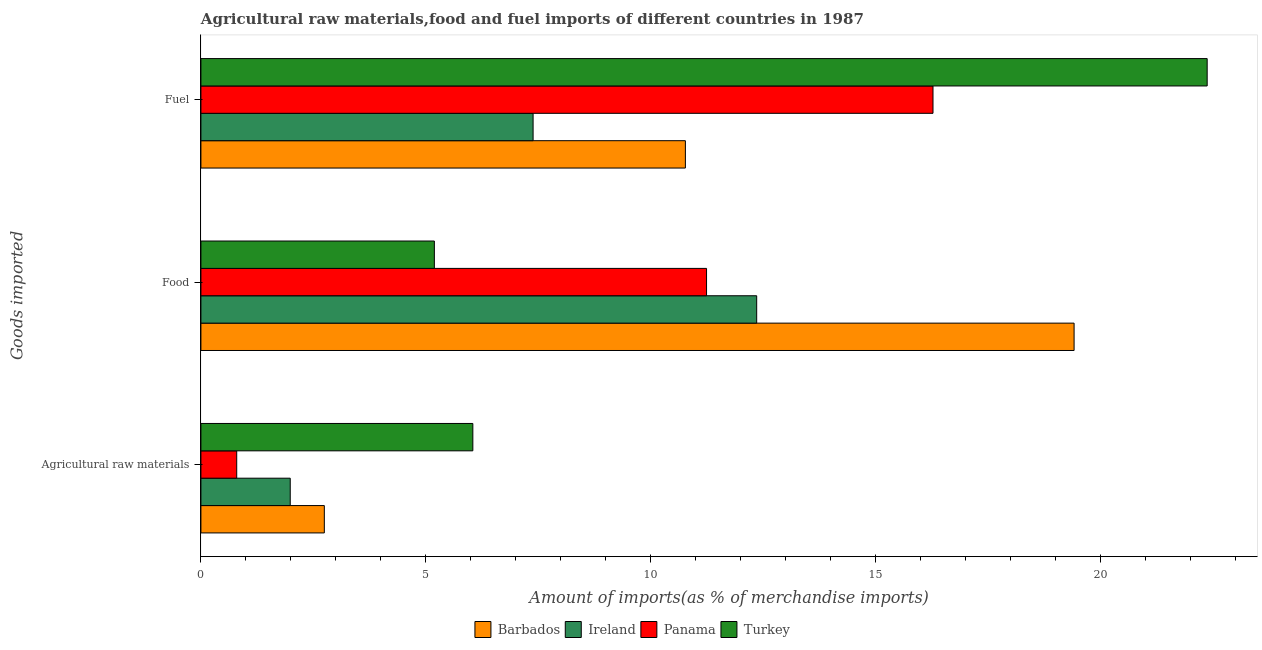How many different coloured bars are there?
Offer a very short reply. 4. How many bars are there on the 3rd tick from the top?
Provide a short and direct response. 4. What is the label of the 3rd group of bars from the top?
Offer a terse response. Agricultural raw materials. What is the percentage of fuel imports in Ireland?
Your answer should be very brief. 7.38. Across all countries, what is the maximum percentage of food imports?
Provide a succinct answer. 19.41. Across all countries, what is the minimum percentage of fuel imports?
Give a very brief answer. 7.38. In which country was the percentage of fuel imports maximum?
Your answer should be compact. Turkey. In which country was the percentage of fuel imports minimum?
Provide a succinct answer. Ireland. What is the total percentage of fuel imports in the graph?
Provide a short and direct response. 56.78. What is the difference between the percentage of fuel imports in Ireland and that in Panama?
Provide a short and direct response. -8.89. What is the difference between the percentage of raw materials imports in Ireland and the percentage of food imports in Turkey?
Your response must be concise. -3.2. What is the average percentage of fuel imports per country?
Your response must be concise. 14.2. What is the difference between the percentage of raw materials imports and percentage of food imports in Ireland?
Offer a terse response. -10.37. In how many countries, is the percentage of fuel imports greater than 12 %?
Keep it short and to the point. 2. What is the ratio of the percentage of raw materials imports in Turkey to that in Barbados?
Give a very brief answer. 2.2. Is the percentage of food imports in Turkey less than that in Panama?
Your answer should be compact. Yes. Is the difference between the percentage of fuel imports in Ireland and Panama greater than the difference between the percentage of raw materials imports in Ireland and Panama?
Keep it short and to the point. No. What is the difference between the highest and the second highest percentage of raw materials imports?
Ensure brevity in your answer.  3.3. What is the difference between the highest and the lowest percentage of fuel imports?
Your answer should be very brief. 14.98. Is the sum of the percentage of raw materials imports in Barbados and Ireland greater than the maximum percentage of fuel imports across all countries?
Ensure brevity in your answer.  No. What does the 3rd bar from the top in Food represents?
Ensure brevity in your answer.  Ireland. What does the 3rd bar from the bottom in Agricultural raw materials represents?
Offer a very short reply. Panama. Is it the case that in every country, the sum of the percentage of raw materials imports and percentage of food imports is greater than the percentage of fuel imports?
Your answer should be very brief. No. Does the graph contain any zero values?
Your answer should be compact. No. Does the graph contain grids?
Your response must be concise. No. How many legend labels are there?
Provide a succinct answer. 4. How are the legend labels stacked?
Offer a very short reply. Horizontal. What is the title of the graph?
Make the answer very short. Agricultural raw materials,food and fuel imports of different countries in 1987. What is the label or title of the X-axis?
Your response must be concise. Amount of imports(as % of merchandise imports). What is the label or title of the Y-axis?
Offer a terse response. Goods imported. What is the Amount of imports(as % of merchandise imports) of Barbados in Agricultural raw materials?
Keep it short and to the point. 2.74. What is the Amount of imports(as % of merchandise imports) of Ireland in Agricultural raw materials?
Give a very brief answer. 1.99. What is the Amount of imports(as % of merchandise imports) of Panama in Agricultural raw materials?
Provide a succinct answer. 0.8. What is the Amount of imports(as % of merchandise imports) in Turkey in Agricultural raw materials?
Offer a very short reply. 6.04. What is the Amount of imports(as % of merchandise imports) of Barbados in Food?
Your response must be concise. 19.41. What is the Amount of imports(as % of merchandise imports) in Ireland in Food?
Offer a terse response. 12.35. What is the Amount of imports(as % of merchandise imports) in Panama in Food?
Provide a short and direct response. 11.24. What is the Amount of imports(as % of merchandise imports) of Turkey in Food?
Offer a very short reply. 5.19. What is the Amount of imports(as % of merchandise imports) in Barbados in Fuel?
Keep it short and to the point. 10.77. What is the Amount of imports(as % of merchandise imports) of Ireland in Fuel?
Provide a short and direct response. 7.38. What is the Amount of imports(as % of merchandise imports) in Panama in Fuel?
Provide a succinct answer. 16.27. What is the Amount of imports(as % of merchandise imports) of Turkey in Fuel?
Your response must be concise. 22.36. Across all Goods imported, what is the maximum Amount of imports(as % of merchandise imports) of Barbados?
Offer a terse response. 19.41. Across all Goods imported, what is the maximum Amount of imports(as % of merchandise imports) of Ireland?
Provide a short and direct response. 12.35. Across all Goods imported, what is the maximum Amount of imports(as % of merchandise imports) of Panama?
Offer a terse response. 16.27. Across all Goods imported, what is the maximum Amount of imports(as % of merchandise imports) in Turkey?
Keep it short and to the point. 22.36. Across all Goods imported, what is the minimum Amount of imports(as % of merchandise imports) in Barbados?
Your answer should be compact. 2.74. Across all Goods imported, what is the minimum Amount of imports(as % of merchandise imports) in Ireland?
Keep it short and to the point. 1.99. Across all Goods imported, what is the minimum Amount of imports(as % of merchandise imports) of Panama?
Offer a very short reply. 0.8. Across all Goods imported, what is the minimum Amount of imports(as % of merchandise imports) of Turkey?
Keep it short and to the point. 5.19. What is the total Amount of imports(as % of merchandise imports) in Barbados in the graph?
Provide a succinct answer. 32.92. What is the total Amount of imports(as % of merchandise imports) of Ireland in the graph?
Your answer should be compact. 21.72. What is the total Amount of imports(as % of merchandise imports) of Panama in the graph?
Provide a short and direct response. 28.3. What is the total Amount of imports(as % of merchandise imports) in Turkey in the graph?
Ensure brevity in your answer.  33.59. What is the difference between the Amount of imports(as % of merchandise imports) in Barbados in Agricultural raw materials and that in Food?
Your answer should be compact. -16.66. What is the difference between the Amount of imports(as % of merchandise imports) in Ireland in Agricultural raw materials and that in Food?
Give a very brief answer. -10.37. What is the difference between the Amount of imports(as % of merchandise imports) of Panama in Agricultural raw materials and that in Food?
Your answer should be very brief. -10.44. What is the difference between the Amount of imports(as % of merchandise imports) in Turkey in Agricultural raw materials and that in Food?
Your answer should be compact. 0.86. What is the difference between the Amount of imports(as % of merchandise imports) of Barbados in Agricultural raw materials and that in Fuel?
Make the answer very short. -8.02. What is the difference between the Amount of imports(as % of merchandise imports) of Ireland in Agricultural raw materials and that in Fuel?
Provide a short and direct response. -5.4. What is the difference between the Amount of imports(as % of merchandise imports) of Panama in Agricultural raw materials and that in Fuel?
Ensure brevity in your answer.  -15.47. What is the difference between the Amount of imports(as % of merchandise imports) of Turkey in Agricultural raw materials and that in Fuel?
Provide a short and direct response. -16.32. What is the difference between the Amount of imports(as % of merchandise imports) of Barbados in Food and that in Fuel?
Provide a succinct answer. 8.64. What is the difference between the Amount of imports(as % of merchandise imports) of Ireland in Food and that in Fuel?
Ensure brevity in your answer.  4.97. What is the difference between the Amount of imports(as % of merchandise imports) of Panama in Food and that in Fuel?
Ensure brevity in your answer.  -5.03. What is the difference between the Amount of imports(as % of merchandise imports) of Turkey in Food and that in Fuel?
Provide a short and direct response. -17.18. What is the difference between the Amount of imports(as % of merchandise imports) of Barbados in Agricultural raw materials and the Amount of imports(as % of merchandise imports) of Ireland in Food?
Your response must be concise. -9.61. What is the difference between the Amount of imports(as % of merchandise imports) of Barbados in Agricultural raw materials and the Amount of imports(as % of merchandise imports) of Panama in Food?
Provide a succinct answer. -8.49. What is the difference between the Amount of imports(as % of merchandise imports) of Barbados in Agricultural raw materials and the Amount of imports(as % of merchandise imports) of Turkey in Food?
Provide a short and direct response. -2.45. What is the difference between the Amount of imports(as % of merchandise imports) in Ireland in Agricultural raw materials and the Amount of imports(as % of merchandise imports) in Panama in Food?
Provide a short and direct response. -9.25. What is the difference between the Amount of imports(as % of merchandise imports) in Ireland in Agricultural raw materials and the Amount of imports(as % of merchandise imports) in Turkey in Food?
Your answer should be very brief. -3.2. What is the difference between the Amount of imports(as % of merchandise imports) in Panama in Agricultural raw materials and the Amount of imports(as % of merchandise imports) in Turkey in Food?
Give a very brief answer. -4.39. What is the difference between the Amount of imports(as % of merchandise imports) of Barbados in Agricultural raw materials and the Amount of imports(as % of merchandise imports) of Ireland in Fuel?
Make the answer very short. -4.64. What is the difference between the Amount of imports(as % of merchandise imports) in Barbados in Agricultural raw materials and the Amount of imports(as % of merchandise imports) in Panama in Fuel?
Offer a terse response. -13.53. What is the difference between the Amount of imports(as % of merchandise imports) of Barbados in Agricultural raw materials and the Amount of imports(as % of merchandise imports) of Turkey in Fuel?
Make the answer very short. -19.62. What is the difference between the Amount of imports(as % of merchandise imports) of Ireland in Agricultural raw materials and the Amount of imports(as % of merchandise imports) of Panama in Fuel?
Provide a succinct answer. -14.28. What is the difference between the Amount of imports(as % of merchandise imports) of Ireland in Agricultural raw materials and the Amount of imports(as % of merchandise imports) of Turkey in Fuel?
Offer a terse response. -20.38. What is the difference between the Amount of imports(as % of merchandise imports) in Panama in Agricultural raw materials and the Amount of imports(as % of merchandise imports) in Turkey in Fuel?
Offer a terse response. -21.57. What is the difference between the Amount of imports(as % of merchandise imports) in Barbados in Food and the Amount of imports(as % of merchandise imports) in Ireland in Fuel?
Your answer should be compact. 12.02. What is the difference between the Amount of imports(as % of merchandise imports) in Barbados in Food and the Amount of imports(as % of merchandise imports) in Panama in Fuel?
Offer a very short reply. 3.14. What is the difference between the Amount of imports(as % of merchandise imports) of Barbados in Food and the Amount of imports(as % of merchandise imports) of Turkey in Fuel?
Offer a terse response. -2.96. What is the difference between the Amount of imports(as % of merchandise imports) in Ireland in Food and the Amount of imports(as % of merchandise imports) in Panama in Fuel?
Your answer should be very brief. -3.92. What is the difference between the Amount of imports(as % of merchandise imports) of Ireland in Food and the Amount of imports(as % of merchandise imports) of Turkey in Fuel?
Provide a succinct answer. -10.01. What is the difference between the Amount of imports(as % of merchandise imports) in Panama in Food and the Amount of imports(as % of merchandise imports) in Turkey in Fuel?
Make the answer very short. -11.13. What is the average Amount of imports(as % of merchandise imports) of Barbados per Goods imported?
Ensure brevity in your answer.  10.97. What is the average Amount of imports(as % of merchandise imports) in Ireland per Goods imported?
Provide a succinct answer. 7.24. What is the average Amount of imports(as % of merchandise imports) of Panama per Goods imported?
Provide a succinct answer. 9.43. What is the average Amount of imports(as % of merchandise imports) of Turkey per Goods imported?
Ensure brevity in your answer.  11.2. What is the difference between the Amount of imports(as % of merchandise imports) in Barbados and Amount of imports(as % of merchandise imports) in Ireland in Agricultural raw materials?
Offer a very short reply. 0.76. What is the difference between the Amount of imports(as % of merchandise imports) of Barbados and Amount of imports(as % of merchandise imports) of Panama in Agricultural raw materials?
Offer a very short reply. 1.95. What is the difference between the Amount of imports(as % of merchandise imports) of Barbados and Amount of imports(as % of merchandise imports) of Turkey in Agricultural raw materials?
Your response must be concise. -3.3. What is the difference between the Amount of imports(as % of merchandise imports) of Ireland and Amount of imports(as % of merchandise imports) of Panama in Agricultural raw materials?
Your response must be concise. 1.19. What is the difference between the Amount of imports(as % of merchandise imports) of Ireland and Amount of imports(as % of merchandise imports) of Turkey in Agricultural raw materials?
Offer a terse response. -4.06. What is the difference between the Amount of imports(as % of merchandise imports) of Panama and Amount of imports(as % of merchandise imports) of Turkey in Agricultural raw materials?
Offer a very short reply. -5.25. What is the difference between the Amount of imports(as % of merchandise imports) in Barbados and Amount of imports(as % of merchandise imports) in Ireland in Food?
Offer a terse response. 7.05. What is the difference between the Amount of imports(as % of merchandise imports) of Barbados and Amount of imports(as % of merchandise imports) of Panama in Food?
Provide a short and direct response. 8.17. What is the difference between the Amount of imports(as % of merchandise imports) in Barbados and Amount of imports(as % of merchandise imports) in Turkey in Food?
Your response must be concise. 14.22. What is the difference between the Amount of imports(as % of merchandise imports) in Ireland and Amount of imports(as % of merchandise imports) in Panama in Food?
Provide a succinct answer. 1.11. What is the difference between the Amount of imports(as % of merchandise imports) in Ireland and Amount of imports(as % of merchandise imports) in Turkey in Food?
Ensure brevity in your answer.  7.16. What is the difference between the Amount of imports(as % of merchandise imports) in Panama and Amount of imports(as % of merchandise imports) in Turkey in Food?
Keep it short and to the point. 6.05. What is the difference between the Amount of imports(as % of merchandise imports) in Barbados and Amount of imports(as % of merchandise imports) in Ireland in Fuel?
Keep it short and to the point. 3.38. What is the difference between the Amount of imports(as % of merchandise imports) of Barbados and Amount of imports(as % of merchandise imports) of Panama in Fuel?
Offer a terse response. -5.5. What is the difference between the Amount of imports(as % of merchandise imports) of Barbados and Amount of imports(as % of merchandise imports) of Turkey in Fuel?
Provide a succinct answer. -11.6. What is the difference between the Amount of imports(as % of merchandise imports) of Ireland and Amount of imports(as % of merchandise imports) of Panama in Fuel?
Give a very brief answer. -8.89. What is the difference between the Amount of imports(as % of merchandise imports) in Ireland and Amount of imports(as % of merchandise imports) in Turkey in Fuel?
Your answer should be compact. -14.98. What is the difference between the Amount of imports(as % of merchandise imports) of Panama and Amount of imports(as % of merchandise imports) of Turkey in Fuel?
Provide a succinct answer. -6.09. What is the ratio of the Amount of imports(as % of merchandise imports) of Barbados in Agricultural raw materials to that in Food?
Make the answer very short. 0.14. What is the ratio of the Amount of imports(as % of merchandise imports) in Ireland in Agricultural raw materials to that in Food?
Provide a succinct answer. 0.16. What is the ratio of the Amount of imports(as % of merchandise imports) of Panama in Agricultural raw materials to that in Food?
Ensure brevity in your answer.  0.07. What is the ratio of the Amount of imports(as % of merchandise imports) in Turkey in Agricultural raw materials to that in Food?
Make the answer very short. 1.16. What is the ratio of the Amount of imports(as % of merchandise imports) of Barbados in Agricultural raw materials to that in Fuel?
Offer a terse response. 0.25. What is the ratio of the Amount of imports(as % of merchandise imports) of Ireland in Agricultural raw materials to that in Fuel?
Provide a succinct answer. 0.27. What is the ratio of the Amount of imports(as % of merchandise imports) of Panama in Agricultural raw materials to that in Fuel?
Make the answer very short. 0.05. What is the ratio of the Amount of imports(as % of merchandise imports) of Turkey in Agricultural raw materials to that in Fuel?
Make the answer very short. 0.27. What is the ratio of the Amount of imports(as % of merchandise imports) of Barbados in Food to that in Fuel?
Offer a very short reply. 1.8. What is the ratio of the Amount of imports(as % of merchandise imports) of Ireland in Food to that in Fuel?
Provide a succinct answer. 1.67. What is the ratio of the Amount of imports(as % of merchandise imports) of Panama in Food to that in Fuel?
Ensure brevity in your answer.  0.69. What is the ratio of the Amount of imports(as % of merchandise imports) of Turkey in Food to that in Fuel?
Give a very brief answer. 0.23. What is the difference between the highest and the second highest Amount of imports(as % of merchandise imports) of Barbados?
Your answer should be compact. 8.64. What is the difference between the highest and the second highest Amount of imports(as % of merchandise imports) in Ireland?
Give a very brief answer. 4.97. What is the difference between the highest and the second highest Amount of imports(as % of merchandise imports) of Panama?
Your answer should be compact. 5.03. What is the difference between the highest and the second highest Amount of imports(as % of merchandise imports) in Turkey?
Offer a very short reply. 16.32. What is the difference between the highest and the lowest Amount of imports(as % of merchandise imports) of Barbados?
Make the answer very short. 16.66. What is the difference between the highest and the lowest Amount of imports(as % of merchandise imports) of Ireland?
Your answer should be very brief. 10.37. What is the difference between the highest and the lowest Amount of imports(as % of merchandise imports) in Panama?
Your answer should be very brief. 15.47. What is the difference between the highest and the lowest Amount of imports(as % of merchandise imports) in Turkey?
Offer a terse response. 17.18. 